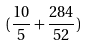Convert formula to latex. <formula><loc_0><loc_0><loc_500><loc_500>( \frac { 1 0 } { 5 } + \frac { 2 8 4 } { 5 2 } )</formula> 